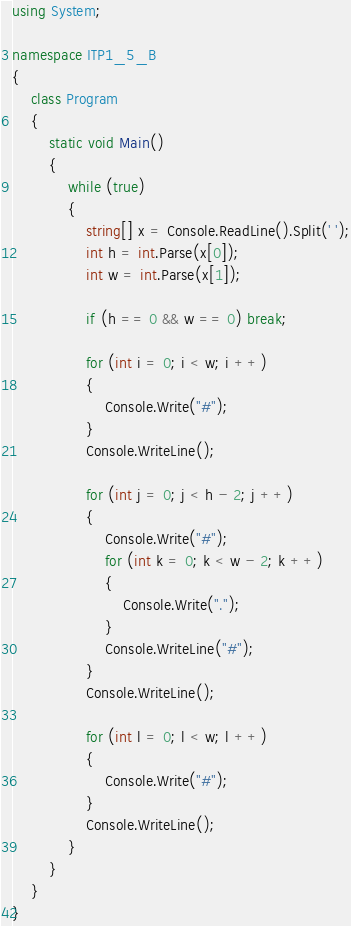<code> <loc_0><loc_0><loc_500><loc_500><_C#_>using System;

namespace ITP1_5_B
{
    class Program
    {
        static void Main()
        {
            while (true)
            {
                string[] x = Console.ReadLine().Split(' ');
                int h = int.Parse(x[0]);
                int w = int.Parse(x[1]);
                
                if (h == 0 && w == 0) break;
                
                for (int i = 0; i < w; i ++)
                {
                    Console.Write("#");
                }
                Console.WriteLine();
                
                for (int j = 0; j < h - 2; j ++)
                {
                    Console.Write("#");
                    for (int k = 0; k < w - 2; k ++)
                    {
                        Console.Write(".");
                    }
                    Console.WriteLine("#");
                }
                Console.WriteLine();
                
                for (int l = 0; l < w; l ++)
                {
                    Console.Write("#");
                }
                Console.WriteLine();
            }
        }
    }
}
</code> 